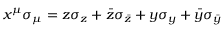<formula> <loc_0><loc_0><loc_500><loc_500>x ^ { \mu } \sigma _ { \mu } = z \sigma _ { z } + \bar { z } \sigma _ { \bar { z } } + y \sigma _ { y } + \bar { y } \sigma _ { \bar { y } }</formula> 